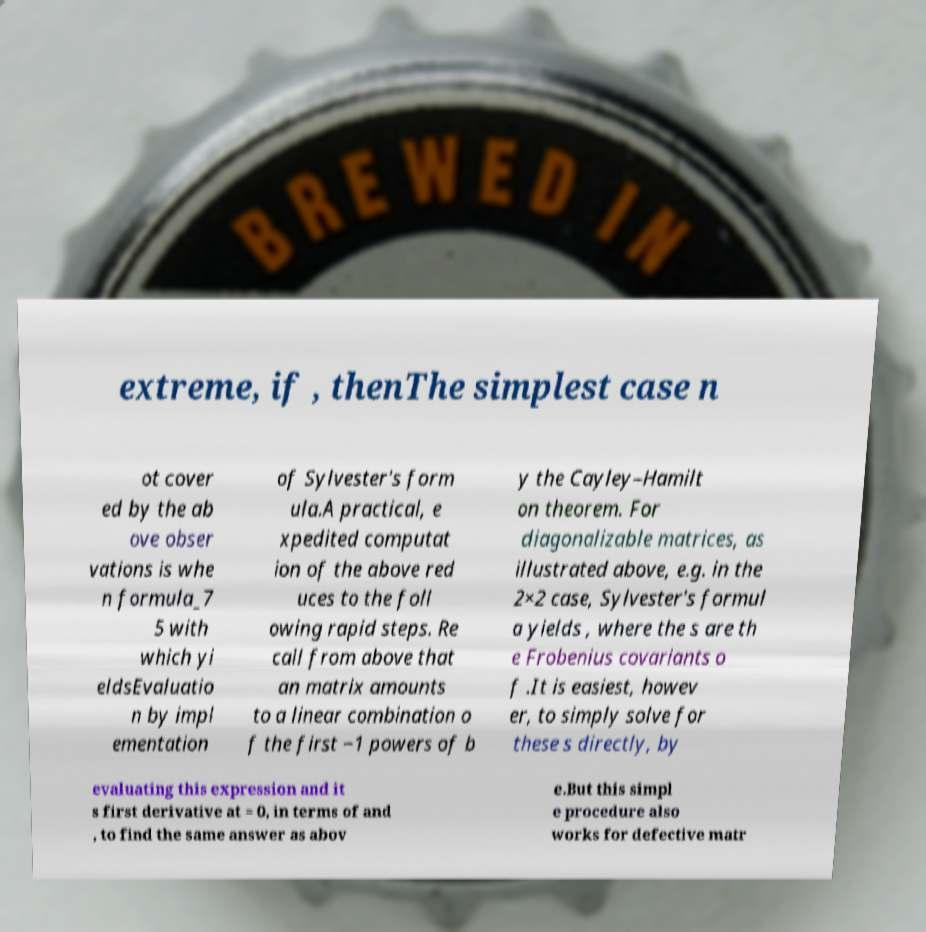Please read and relay the text visible in this image. What does it say? extreme, if , thenThe simplest case n ot cover ed by the ab ove obser vations is whe n formula_7 5 with which yi eldsEvaluatio n by impl ementation of Sylvester's form ula.A practical, e xpedited computat ion of the above red uces to the foll owing rapid steps. Re call from above that an matrix amounts to a linear combination o f the first −1 powers of b y the Cayley–Hamilt on theorem. For diagonalizable matrices, as illustrated above, e.g. in the 2×2 case, Sylvester's formul a yields , where the s are th e Frobenius covariants o f .It is easiest, howev er, to simply solve for these s directly, by evaluating this expression and it s first derivative at = 0, in terms of and , to find the same answer as abov e.But this simpl e procedure also works for defective matr 